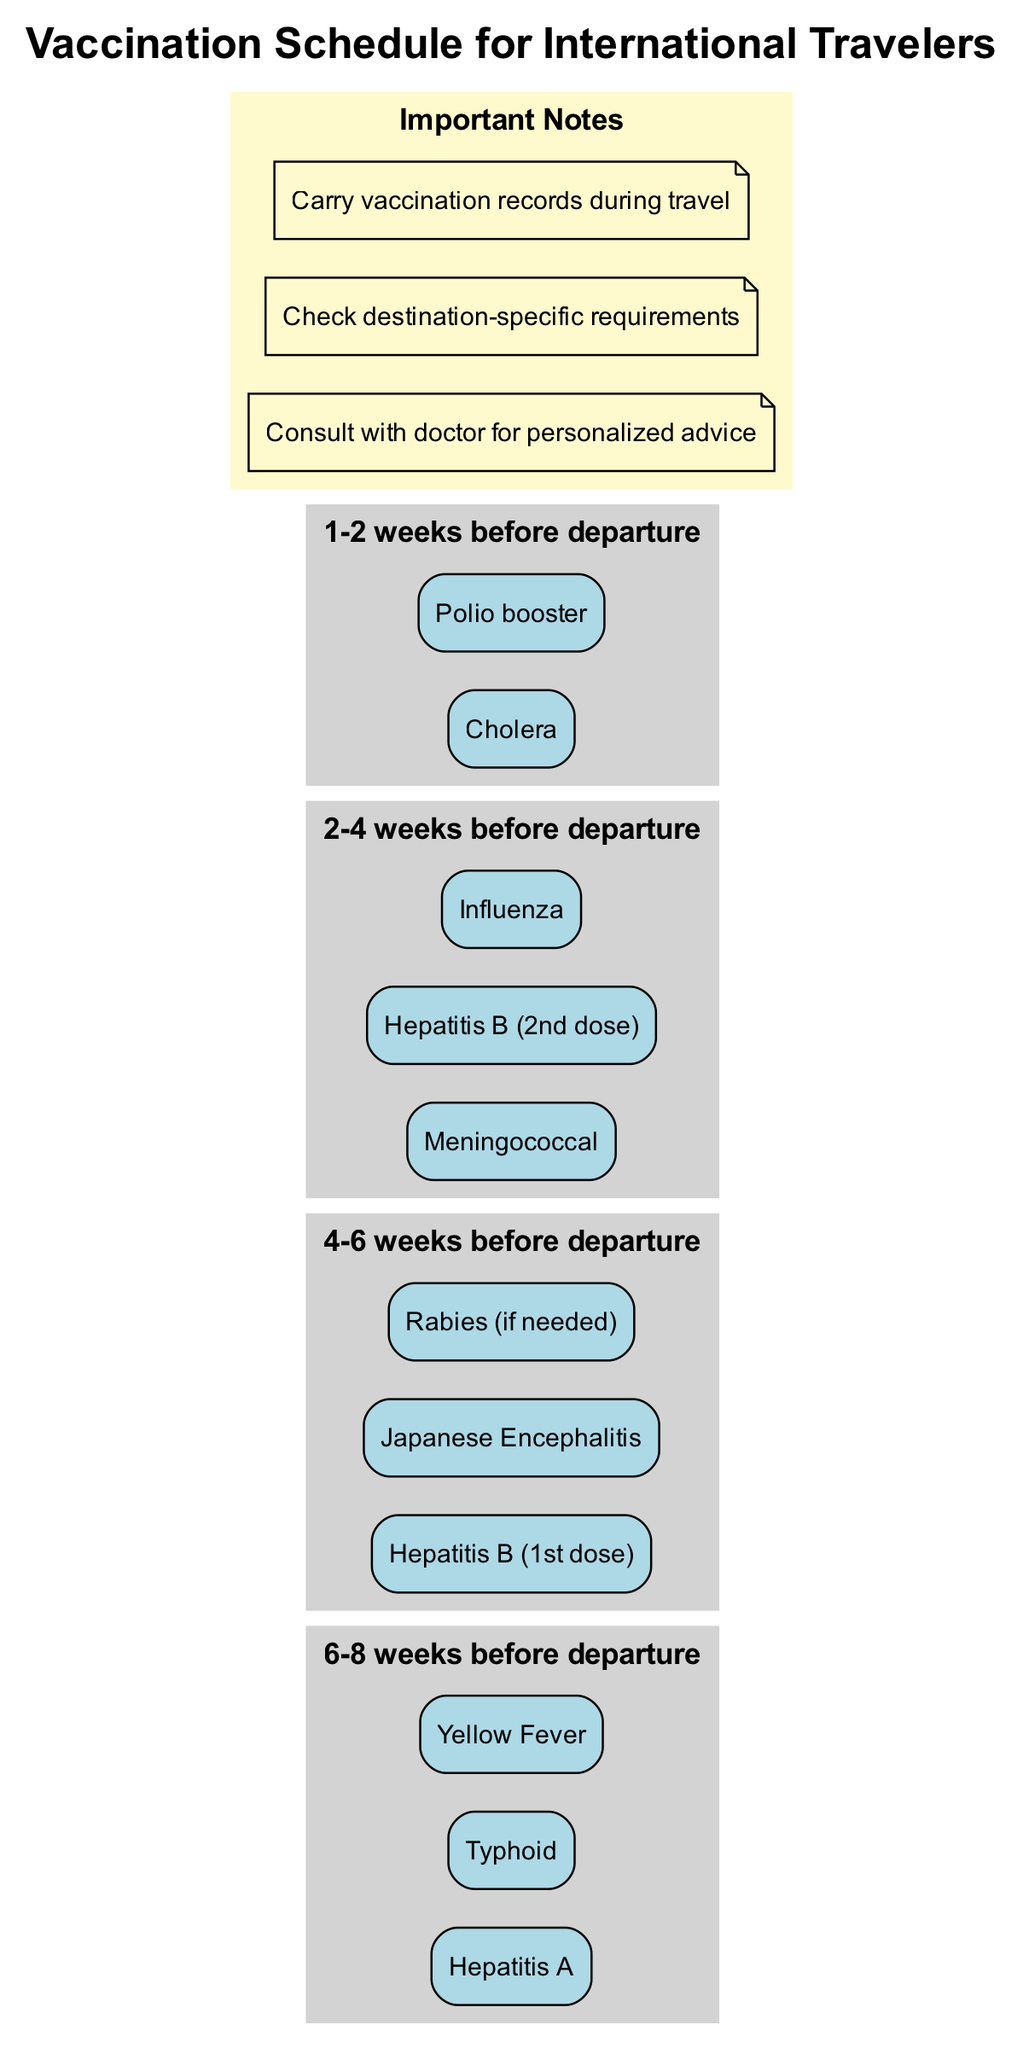What vaccines are recommended 6-8 weeks before departure? The diagram lists "Hepatitis A," "Typhoid," and "Yellow Fever" as the vaccines recommended for this period.
Answer: Hepatitis A, Typhoid, Yellow Fever How many vaccines are listed for the period of 4-6 weeks before departure? In this period, three vaccines are mentioned: "Hepatitis B (1st dose)," "Japanese Encephalitis," and "Rabies (if needed)." Counting these gives a total of three vaccines.
Answer: 3 What is the last vaccine listed before departure? The diagram shows "Polio booster" listed for the period of 1-2 weeks before departure. This is the final vaccine mentioned in the timeline.
Answer: Polio booster Which vaccines are administered during the 2-4 weeks before departure? For this time frame, the diagram indicates "Meningococcal," "Hepatitis B (2nd dose)," and "Influenza" as the vaccines administered. Each vaccine is listed in the timeline section for that period, allowing for straightforward identification.
Answer: Meningococcal, Hepatitis B (2nd dose), Influenza What is the purpose of the important notes section in the diagram? The important notes section provides essential advice such as consulting with a doctor for personalized advice, checking destination-specific requirements, and carrying vaccination records during travel. This information is crucial for travelers but is not directly linked to specific vaccines.
Answer: Consult with doctor for personalized advice, Check destination-specific requirements, Carry vaccination records during travel How many total periods are shown in the vaccination schedule? The diagram contains a total of four distinct periods that outline the recommended vaccine timelines before departure. Counting each clearly labeled time frame gives a total of four.
Answer: 4 Which vaccine is only given if needed according to the schedule? The vaccine "Rabies" is noted as being given only if needed in the 4-6 weeks before departure period. This specificity indicates that not all travelers may require vaccination for Rabies.
Answer: Rabies (if needed) What additional step is required for personalized vaccination advice? The diagram advises consulting with a doctor for personalized advice. This recommendation serves as an important step for individuals to consider their unique health needs.
Answer: Consult with doctor 